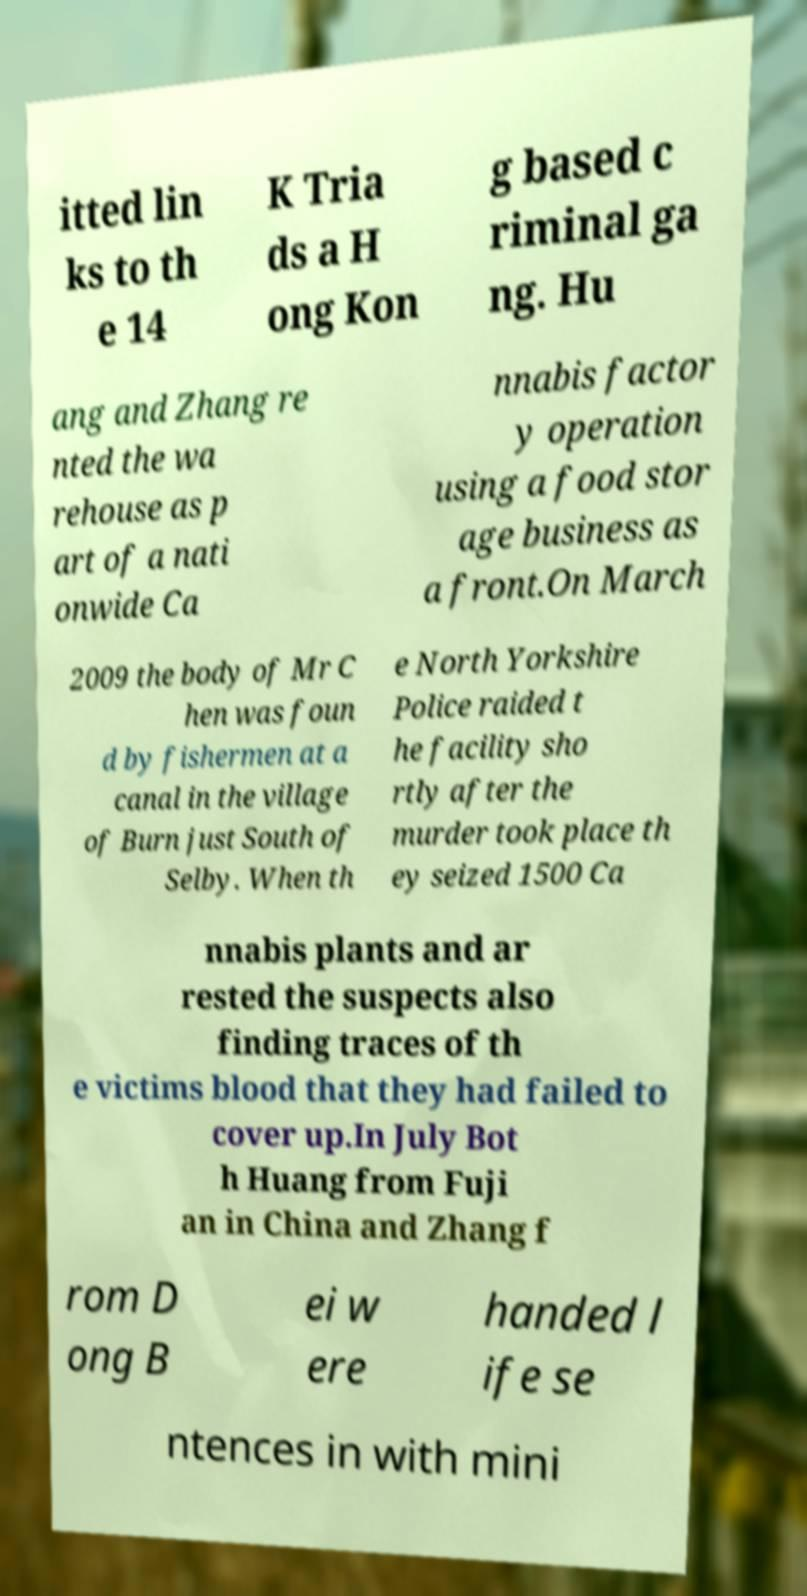Please read and relay the text visible in this image. What does it say? itted lin ks to th e 14 K Tria ds a H ong Kon g based c riminal ga ng. Hu ang and Zhang re nted the wa rehouse as p art of a nati onwide Ca nnabis factor y operation using a food stor age business as a front.On March 2009 the body of Mr C hen was foun d by fishermen at a canal in the village of Burn just South of Selby. When th e North Yorkshire Police raided t he facility sho rtly after the murder took place th ey seized 1500 Ca nnabis plants and ar rested the suspects also finding traces of th e victims blood that they had failed to cover up.In July Bot h Huang from Fuji an in China and Zhang f rom D ong B ei w ere handed l ife se ntences in with mini 